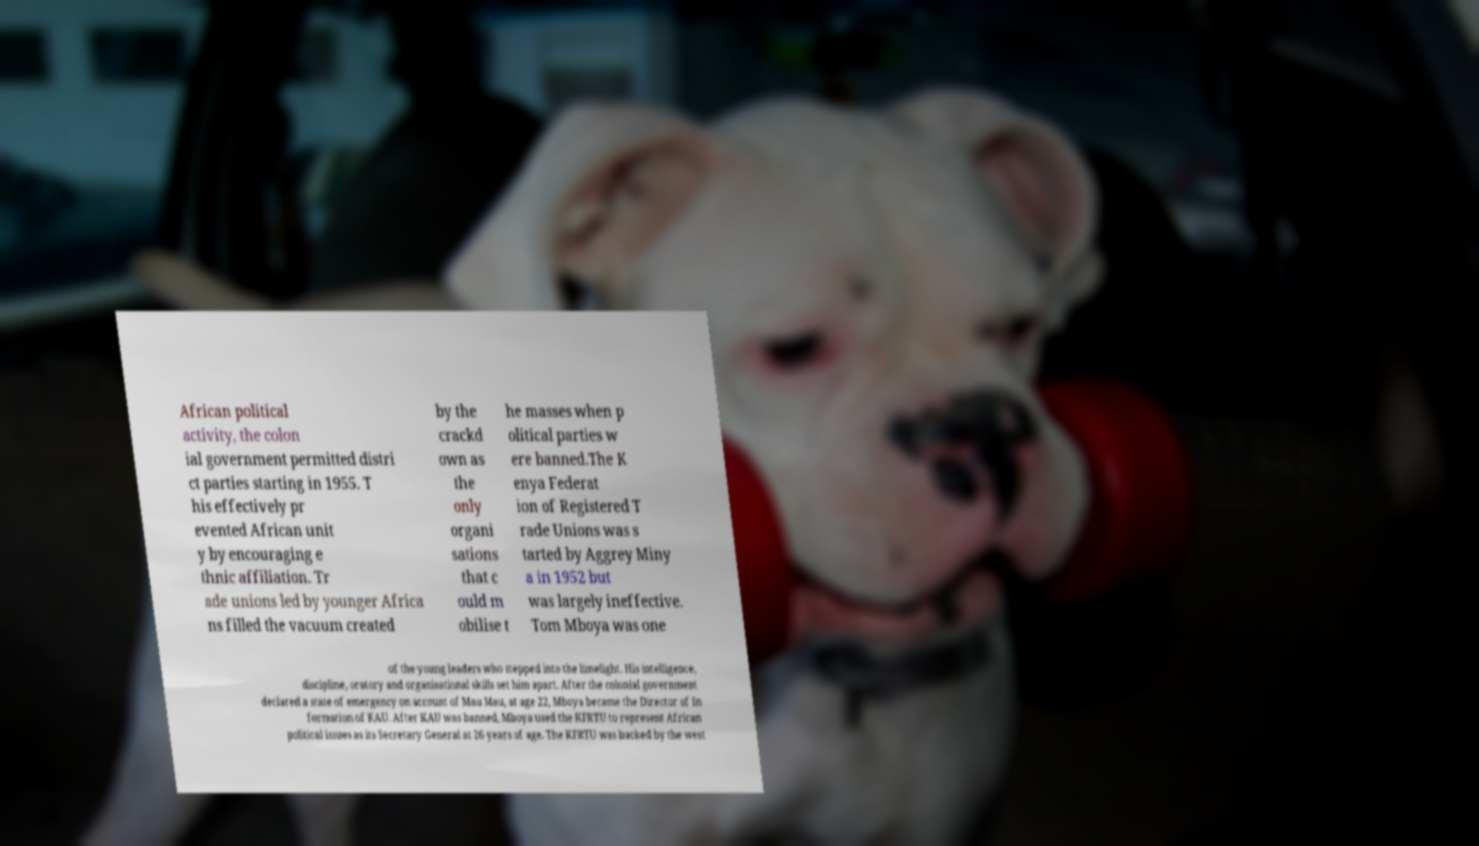Can you accurately transcribe the text from the provided image for me? African political activity, the colon ial government permitted distri ct parties starting in 1955. T his effectively pr evented African unit y by encouraging e thnic affiliation. Tr ade unions led by younger Africa ns filled the vacuum created by the crackd own as the only organi sations that c ould m obilise t he masses when p olitical parties w ere banned.The K enya Federat ion of Registered T rade Unions was s tarted by Aggrey Miny a in 1952 but was largely ineffective. Tom Mboya was one of the young leaders who stepped into the limelight. His intelligence, discipline, oratory and organisational skills set him apart. After the colonial government declared a state of emergency on account of Mau Mau, at age 22, Mboya became the Director of In formation of KAU. After KAU was banned, Mboya used the KFRTU to represent African political issues as its Secretary General at 26 years of age. The KFRTU was backed by the west 